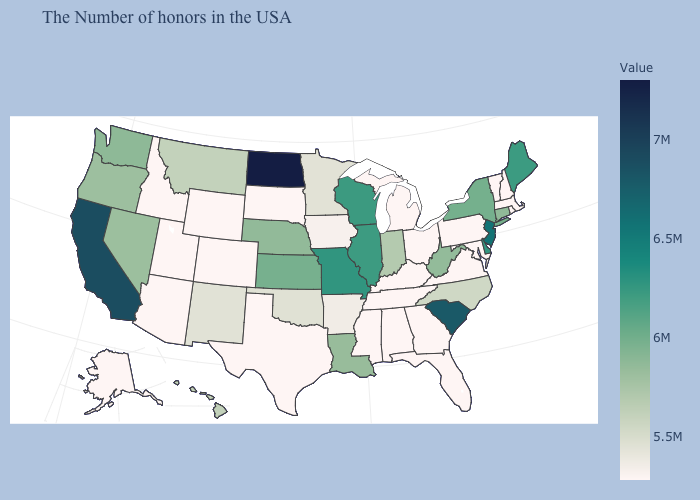Does Massachusetts have the lowest value in the USA?
Answer briefly. Yes. Does Utah have a lower value than North Dakota?
Quick response, please. Yes. Which states have the lowest value in the Northeast?
Write a very short answer. Massachusetts, Rhode Island, New Hampshire, Vermont, Pennsylvania. Among the states that border Delaware , does New Jersey have the lowest value?
Quick response, please. No. Does South Carolina have a higher value than North Dakota?
Keep it brief. No. 